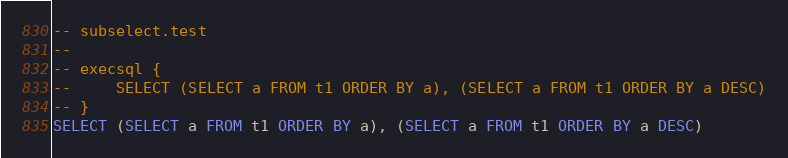<code> <loc_0><loc_0><loc_500><loc_500><_SQL_>-- subselect.test
-- 
-- execsql {
--     SELECT (SELECT a FROM t1 ORDER BY a), (SELECT a FROM t1 ORDER BY a DESC)
-- }
SELECT (SELECT a FROM t1 ORDER BY a), (SELECT a FROM t1 ORDER BY a DESC)</code> 